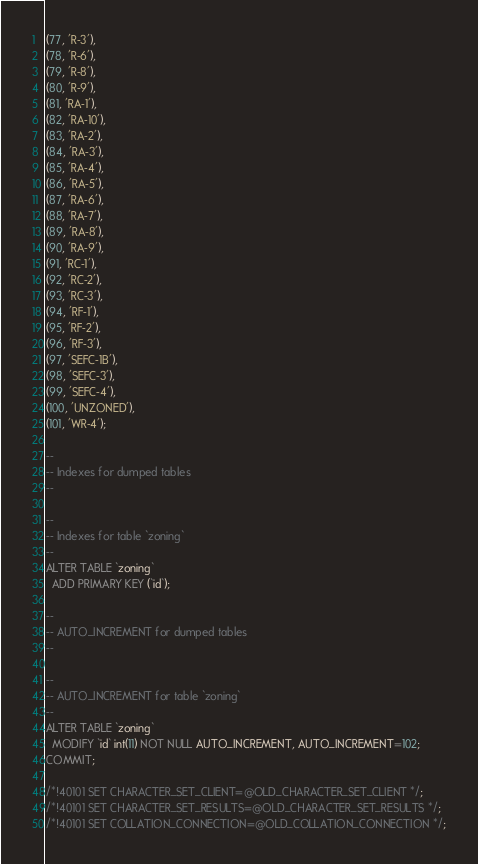Convert code to text. <code><loc_0><loc_0><loc_500><loc_500><_SQL_>(77, 'R-3'),
(78, 'R-6'),
(79, 'R-8'),
(80, 'R-9'),
(81, 'RA-1'),
(82, 'RA-10'),
(83, 'RA-2'),
(84, 'RA-3'),
(85, 'RA-4'),
(86, 'RA-5'),
(87, 'RA-6'),
(88, 'RA-7'),
(89, 'RA-8'),
(90, 'RA-9'),
(91, 'RC-1'),
(92, 'RC-2'),
(93, 'RC-3'),
(94, 'RF-1'),
(95, 'RF-2'),
(96, 'RF-3'),
(97, 'SEFC-1B'),
(98, 'SEFC-3'),
(99, 'SEFC-4'),
(100, 'UNZONED'),
(101, 'WR-4');

--
-- Indexes for dumped tables
--

--
-- Indexes for table `zoning`
--
ALTER TABLE `zoning`
  ADD PRIMARY KEY (`id`);

--
-- AUTO_INCREMENT for dumped tables
--

--
-- AUTO_INCREMENT for table `zoning`
--
ALTER TABLE `zoning`
  MODIFY `id` int(11) NOT NULL AUTO_INCREMENT, AUTO_INCREMENT=102;
COMMIT;

/*!40101 SET CHARACTER_SET_CLIENT=@OLD_CHARACTER_SET_CLIENT */;
/*!40101 SET CHARACTER_SET_RESULTS=@OLD_CHARACTER_SET_RESULTS */;
/*!40101 SET COLLATION_CONNECTION=@OLD_COLLATION_CONNECTION */;
</code> 